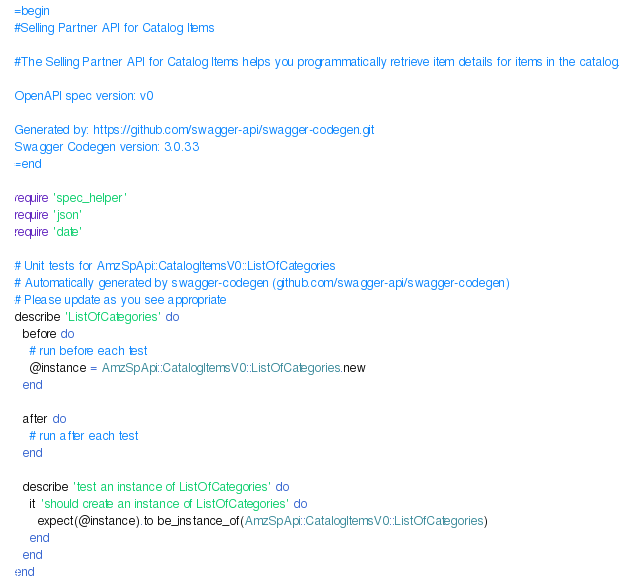Convert code to text. <code><loc_0><loc_0><loc_500><loc_500><_Ruby_>=begin
#Selling Partner API for Catalog Items

#The Selling Partner API for Catalog Items helps you programmatically retrieve item details for items in the catalog.

OpenAPI spec version: v0

Generated by: https://github.com/swagger-api/swagger-codegen.git
Swagger Codegen version: 3.0.33
=end

require 'spec_helper'
require 'json'
require 'date'

# Unit tests for AmzSpApi::CatalogItemsV0::ListOfCategories
# Automatically generated by swagger-codegen (github.com/swagger-api/swagger-codegen)
# Please update as you see appropriate
describe 'ListOfCategories' do
  before do
    # run before each test
    @instance = AmzSpApi::CatalogItemsV0::ListOfCategories.new
  end

  after do
    # run after each test
  end

  describe 'test an instance of ListOfCategories' do
    it 'should create an instance of ListOfCategories' do
      expect(@instance).to be_instance_of(AmzSpApi::CatalogItemsV0::ListOfCategories)
    end
  end
end
</code> 